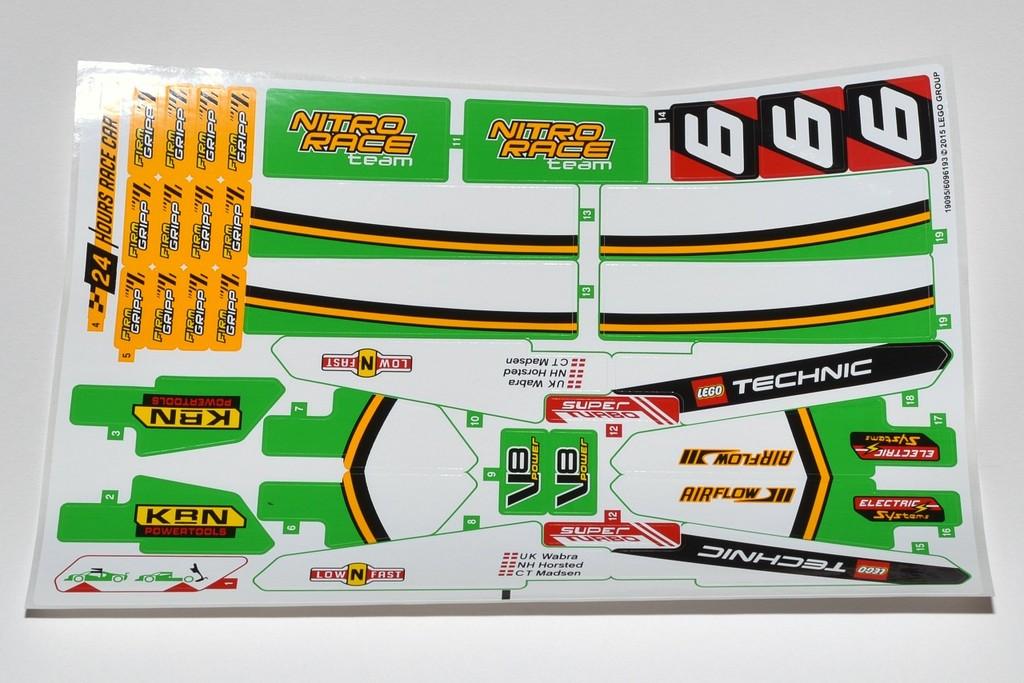What brand name of toy is this?
Keep it short and to the point. Lego. 